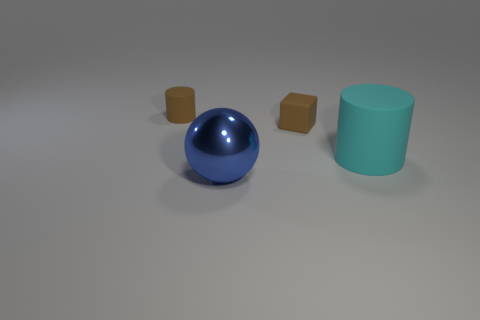What number of other big cyan rubber things are the same shape as the large cyan rubber thing?
Make the answer very short. 0. What is the material of the thing that is the same color as the cube?
Ensure brevity in your answer.  Rubber. How many large blue balls are there?
Offer a very short reply. 1. Does the cyan thing have the same shape as the rubber thing that is behind the cube?
Your answer should be compact. Yes. How many objects are large rubber cylinders or matte cylinders that are right of the small block?
Make the answer very short. 1. What is the material of the small thing that is the same shape as the large cyan rubber thing?
Your response must be concise. Rubber. There is a brown rubber object on the left side of the tiny brown block; is it the same shape as the big cyan matte object?
Make the answer very short. Yes. Is the number of metal spheres right of the brown block less than the number of rubber objects left of the large rubber cylinder?
Your answer should be very brief. Yes. What number of other things are the same shape as the blue thing?
Keep it short and to the point. 0. There is a blue ball that is on the left side of the brown matte object in front of the matte thing on the left side of the blue shiny object; what is its size?
Provide a succinct answer. Large. 